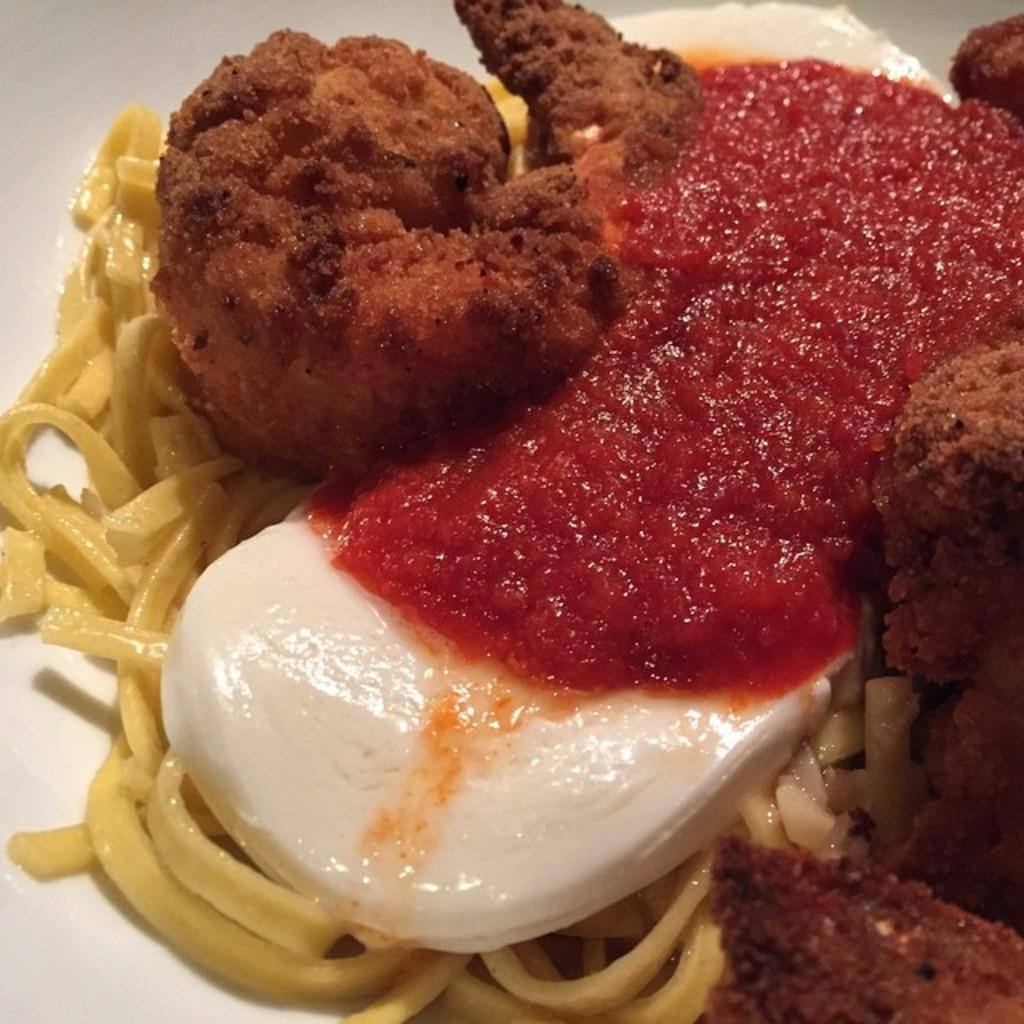What type of food can be seen in the picture? There is a food item in the picture. What is one of the components of the food item? The food item has sauce. What is another component of the food item? The food item has cream. What type of pasta is included in the food item? The food item has spaghetti. What other type of food is present in the dish? The food item has other fried items. What type of drum is visible in the picture? There is no drum present in the picture; it features a food item with various components. How many cups of meat are included in the dish? There is no mention of cups of meat in the dish; the food item consists of sauce, cream, spaghetti, and other fried items. 